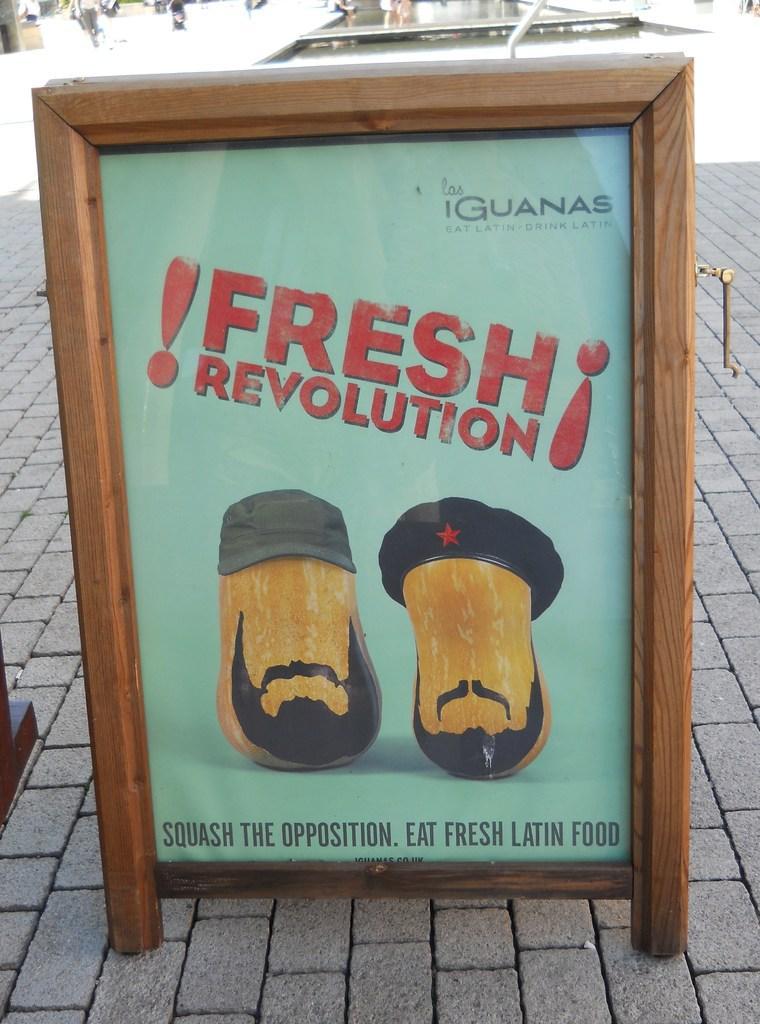Please provide a concise description of this image. There is a hoarding on the footpath. In the background, there are other objects. 